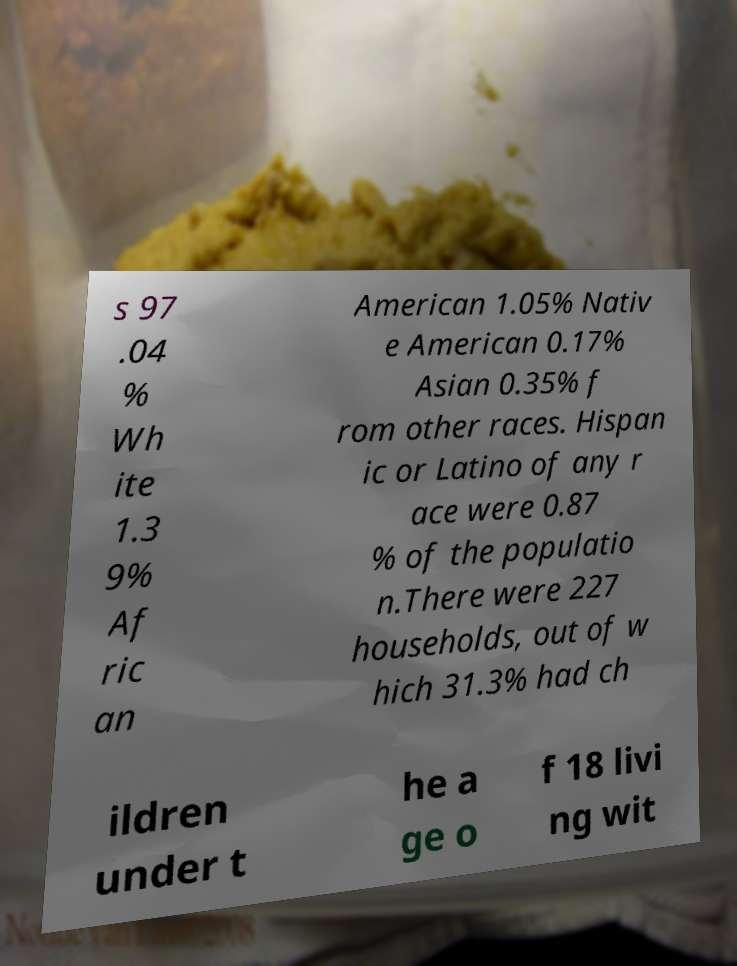Could you assist in decoding the text presented in this image and type it out clearly? s 97 .04 % Wh ite 1.3 9% Af ric an American 1.05% Nativ e American 0.17% Asian 0.35% f rom other races. Hispan ic or Latino of any r ace were 0.87 % of the populatio n.There were 227 households, out of w hich 31.3% had ch ildren under t he a ge o f 18 livi ng wit 